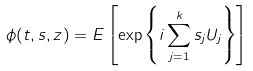Convert formula to latex. <formula><loc_0><loc_0><loc_500><loc_500>\phi ( t , s , z ) = E \left [ \exp \left \{ i \sum _ { j = 1 } ^ { k } s _ { j } U _ { j } \right \} \right ]</formula> 